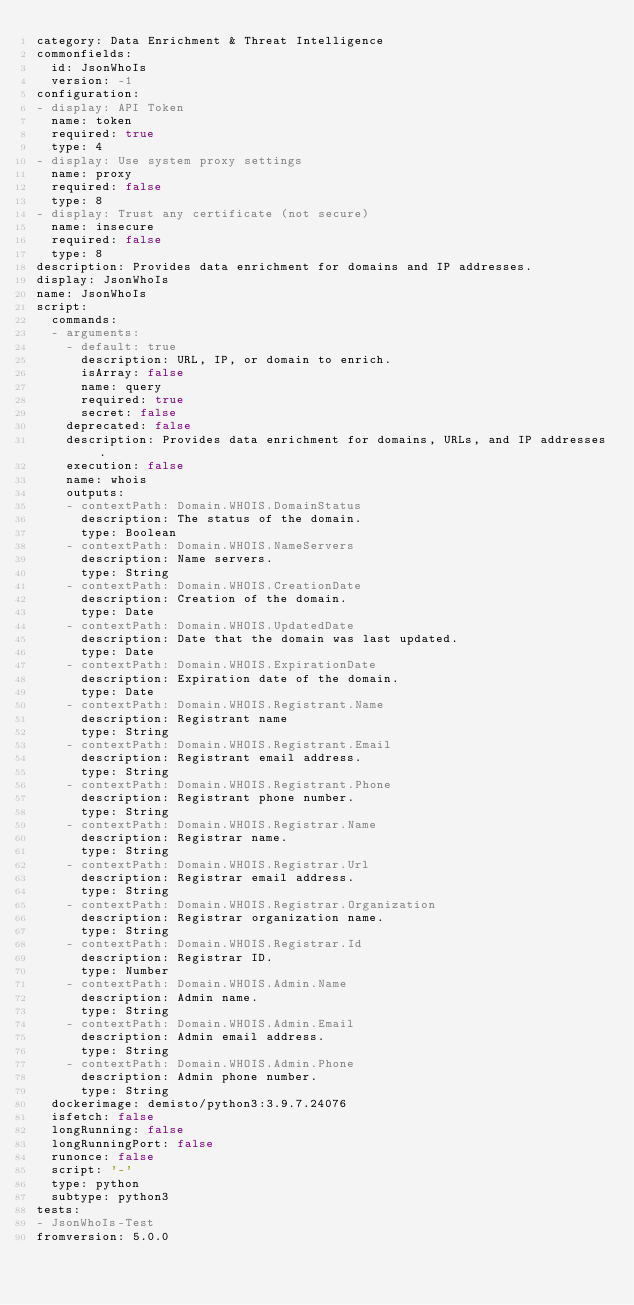<code> <loc_0><loc_0><loc_500><loc_500><_YAML_>category: Data Enrichment & Threat Intelligence
commonfields:
  id: JsonWhoIs
  version: -1
configuration:
- display: API Token
  name: token
  required: true
  type: 4
- display: Use system proxy settings
  name: proxy
  required: false
  type: 8
- display: Trust any certificate (not secure)
  name: insecure
  required: false
  type: 8
description: Provides data enrichment for domains and IP addresses.
display: JsonWhoIs
name: JsonWhoIs
script:
  commands:
  - arguments:
    - default: true
      description: URL, IP, or domain to enrich.
      isArray: false
      name: query
      required: true
      secret: false
    deprecated: false
    description: Provides data enrichment for domains, URLs, and IP addresses.
    execution: false
    name: whois
    outputs:
    - contextPath: Domain.WHOIS.DomainStatus
      description: The status of the domain.
      type: Boolean
    - contextPath: Domain.WHOIS.NameServers
      description: Name servers.
      type: String
    - contextPath: Domain.WHOIS.CreationDate
      description: Creation of the domain.
      type: Date
    - contextPath: Domain.WHOIS.UpdatedDate
      description: Date that the domain was last updated.
      type: Date
    - contextPath: Domain.WHOIS.ExpirationDate
      description: Expiration date of the domain.
      type: Date
    - contextPath: Domain.WHOIS.Registrant.Name
      description: Registrant name
      type: String
    - contextPath: Domain.WHOIS.Registrant.Email
      description: Registrant email address.
      type: String
    - contextPath: Domain.WHOIS.Registrant.Phone
      description: Registrant phone number.
      type: String
    - contextPath: Domain.WHOIS.Registrar.Name
      description: Registrar name.
      type: String
    - contextPath: Domain.WHOIS.Registrar.Url
      description: Registrar email address.
      type: String
    - contextPath: Domain.WHOIS.Registrar.Organization
      description: Registrar organization name.
      type: String
    - contextPath: Domain.WHOIS.Registrar.Id
      description: Registrar ID.
      type: Number
    - contextPath: Domain.WHOIS.Admin.Name
      description: Admin name.
      type: String
    - contextPath: Domain.WHOIS.Admin.Email
      description: Admin email address.
      type: String
    - contextPath: Domain.WHOIS.Admin.Phone
      description: Admin phone number.
      type: String
  dockerimage: demisto/python3:3.9.7.24076
  isfetch: false
  longRunning: false
  longRunningPort: false
  runonce: false
  script: '-'
  type: python
  subtype: python3
tests:
- JsonWhoIs-Test
fromversion: 5.0.0
</code> 